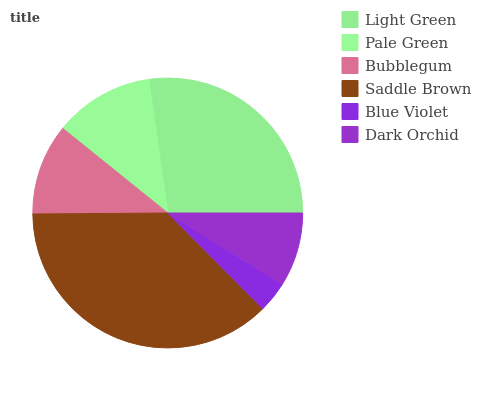Is Blue Violet the minimum?
Answer yes or no. Yes. Is Saddle Brown the maximum?
Answer yes or no. Yes. Is Pale Green the minimum?
Answer yes or no. No. Is Pale Green the maximum?
Answer yes or no. No. Is Light Green greater than Pale Green?
Answer yes or no. Yes. Is Pale Green less than Light Green?
Answer yes or no. Yes. Is Pale Green greater than Light Green?
Answer yes or no. No. Is Light Green less than Pale Green?
Answer yes or no. No. Is Pale Green the high median?
Answer yes or no. Yes. Is Bubblegum the low median?
Answer yes or no. Yes. Is Bubblegum the high median?
Answer yes or no. No. Is Dark Orchid the low median?
Answer yes or no. No. 